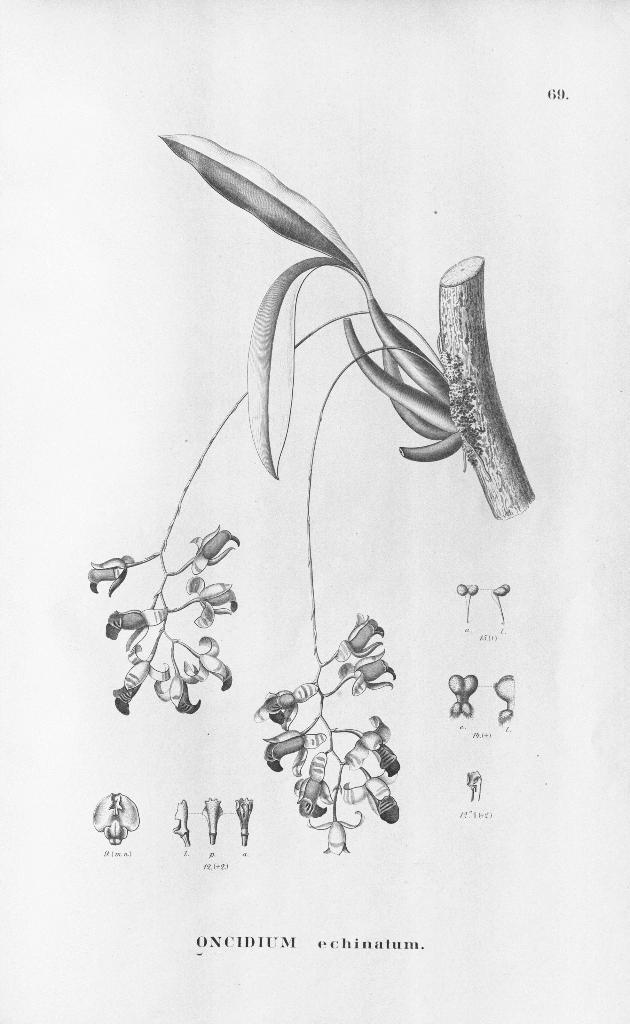Could you give a brief overview of what you see in this image? In this image we can see an art of a plant with flowers where parts are labelled. Here we can see some edited text. 